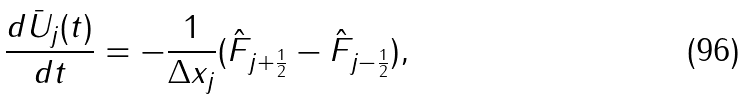<formula> <loc_0><loc_0><loc_500><loc_500>\frac { d \bar { U } _ { j } ( t ) } { d t } = - \frac { 1 } { \Delta { x _ { j } } } ( \hat { F } _ { j + \frac { 1 } { 2 } } - \hat { F } _ { j - \frac { 1 } { 2 } } ) ,</formula> 